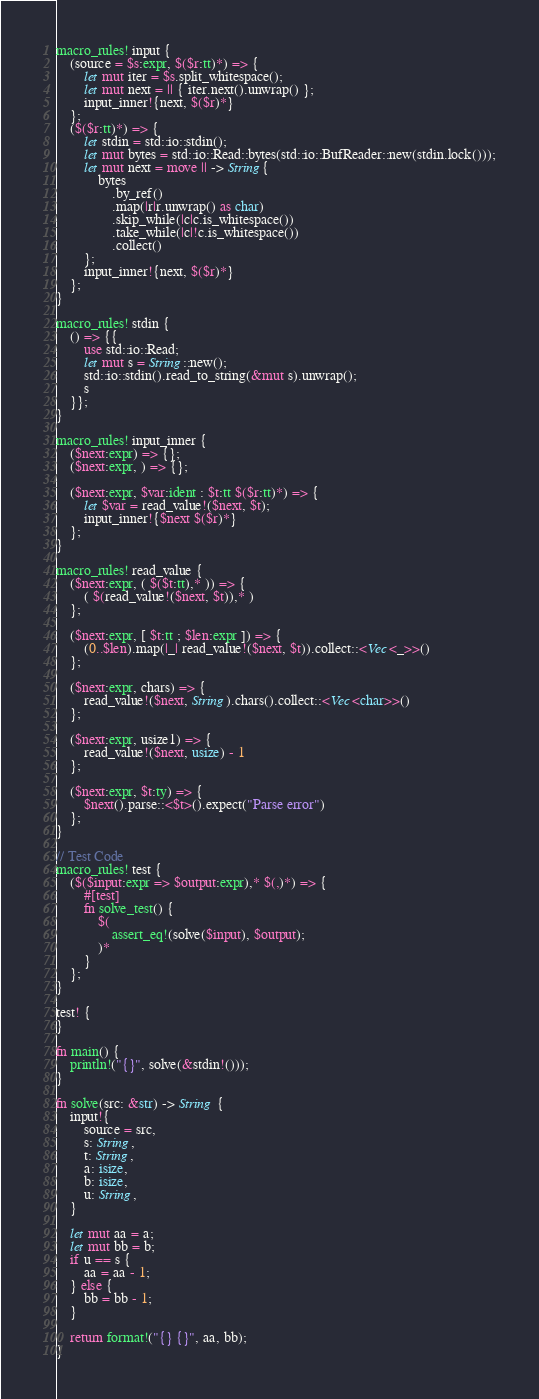Convert code to text. <code><loc_0><loc_0><loc_500><loc_500><_Rust_>macro_rules! input {
    (source = $s:expr, $($r:tt)*) => {
        let mut iter = $s.split_whitespace();
        let mut next = || { iter.next().unwrap() };
        input_inner!{next, $($r)*}
    };
    ($($r:tt)*) => {
        let stdin = std::io::stdin();
        let mut bytes = std::io::Read::bytes(std::io::BufReader::new(stdin.lock()));
        let mut next = move || -> String{
            bytes
                .by_ref()
                .map(|r|r.unwrap() as char)
                .skip_while(|c|c.is_whitespace())
                .take_while(|c|!c.is_whitespace())
                .collect()
        };
        input_inner!{next, $($r)*}
    };
}

macro_rules! stdin {
    () => {{
        use std::io::Read;
        let mut s = String::new();
        std::io::stdin().read_to_string(&mut s).unwrap();
        s
    }};
}

macro_rules! input_inner {
    ($next:expr) => {};
    ($next:expr, ) => {};

    ($next:expr, $var:ident : $t:tt $($r:tt)*) => {
        let $var = read_value!($next, $t);
        input_inner!{$next $($r)*}
    };
}

macro_rules! read_value {
    ($next:expr, ( $($t:tt),* )) => {
        ( $(read_value!($next, $t)),* )
    };

    ($next:expr, [ $t:tt ; $len:expr ]) => {
        (0..$len).map(|_| read_value!($next, $t)).collect::<Vec<_>>()
    };

    ($next:expr, chars) => {
        read_value!($next, String).chars().collect::<Vec<char>>()
    };

    ($next:expr, usize1) => {
        read_value!($next, usize) - 1
    };

    ($next:expr, $t:ty) => {
        $next().parse::<$t>().expect("Parse error")
    };
}

// Test Code
macro_rules! test {
    ($($input:expr => $output:expr),* $(,)*) => {
        #[test]
        fn solve_test() {
            $(
                assert_eq!(solve($input), $output);
            )*
        }
    };
}

test! {
}

fn main() {
    println!("{}", solve(&stdin!()));
}

fn solve(src: &str) -> String {
    input!{
        source = src,
        s: String,
        t: String,
        a: isize,
        b: isize,
        u: String,
    }

    let mut aa = a;
    let mut bb = b;
    if u == s {
        aa = aa - 1;
    } else {
        bb = bb - 1;
    }

    return format!("{} {}", aa, bb);
}
</code> 